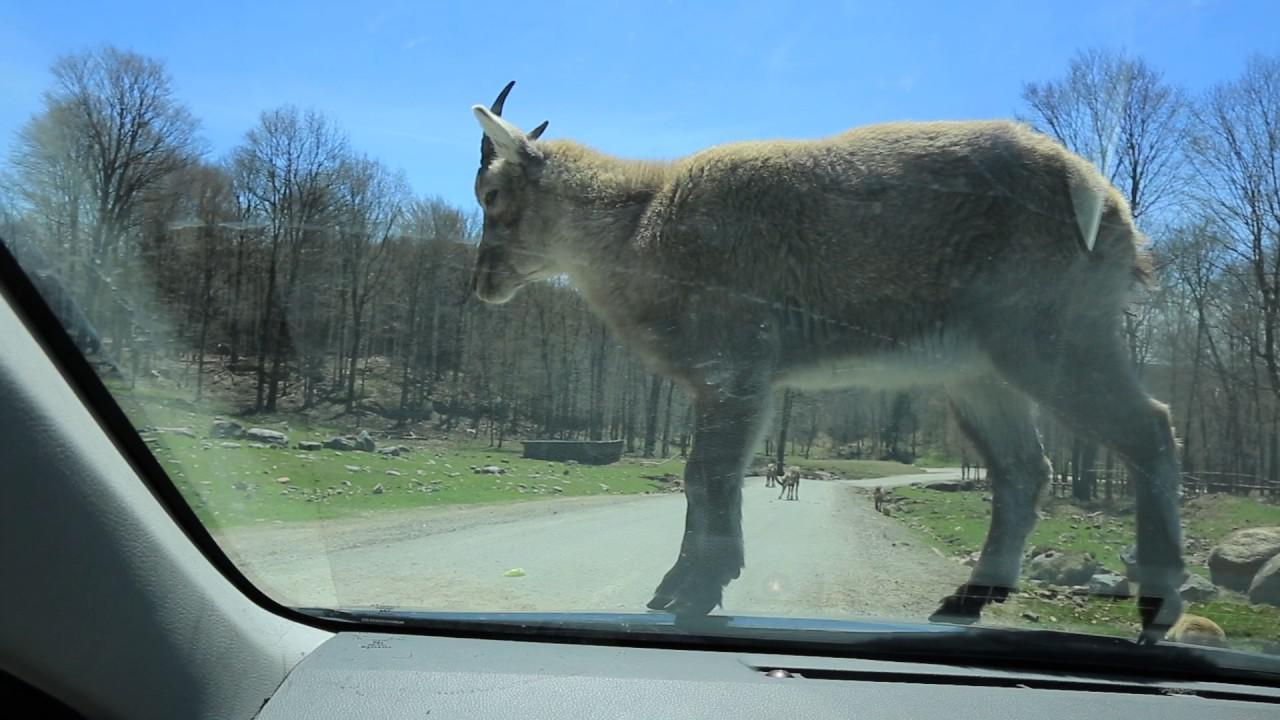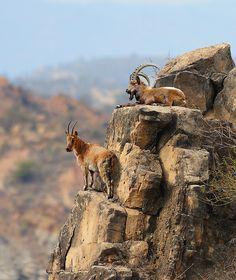The first image is the image on the left, the second image is the image on the right. Evaluate the accuracy of this statement regarding the images: "One image contains one hooved animal with short horns, which is standing on some platform with its body turned leftward.". Is it true? Answer yes or no. Yes. The first image is the image on the left, the second image is the image on the right. Evaluate the accuracy of this statement regarding the images: "There are more rams in the image on the right than in the image on the left.". Is it true? Answer yes or no. Yes. The first image is the image on the left, the second image is the image on the right. Examine the images to the left and right. Is the description "In one image, two animals with large upright horns are perched on a high rocky area." accurate? Answer yes or no. Yes. 